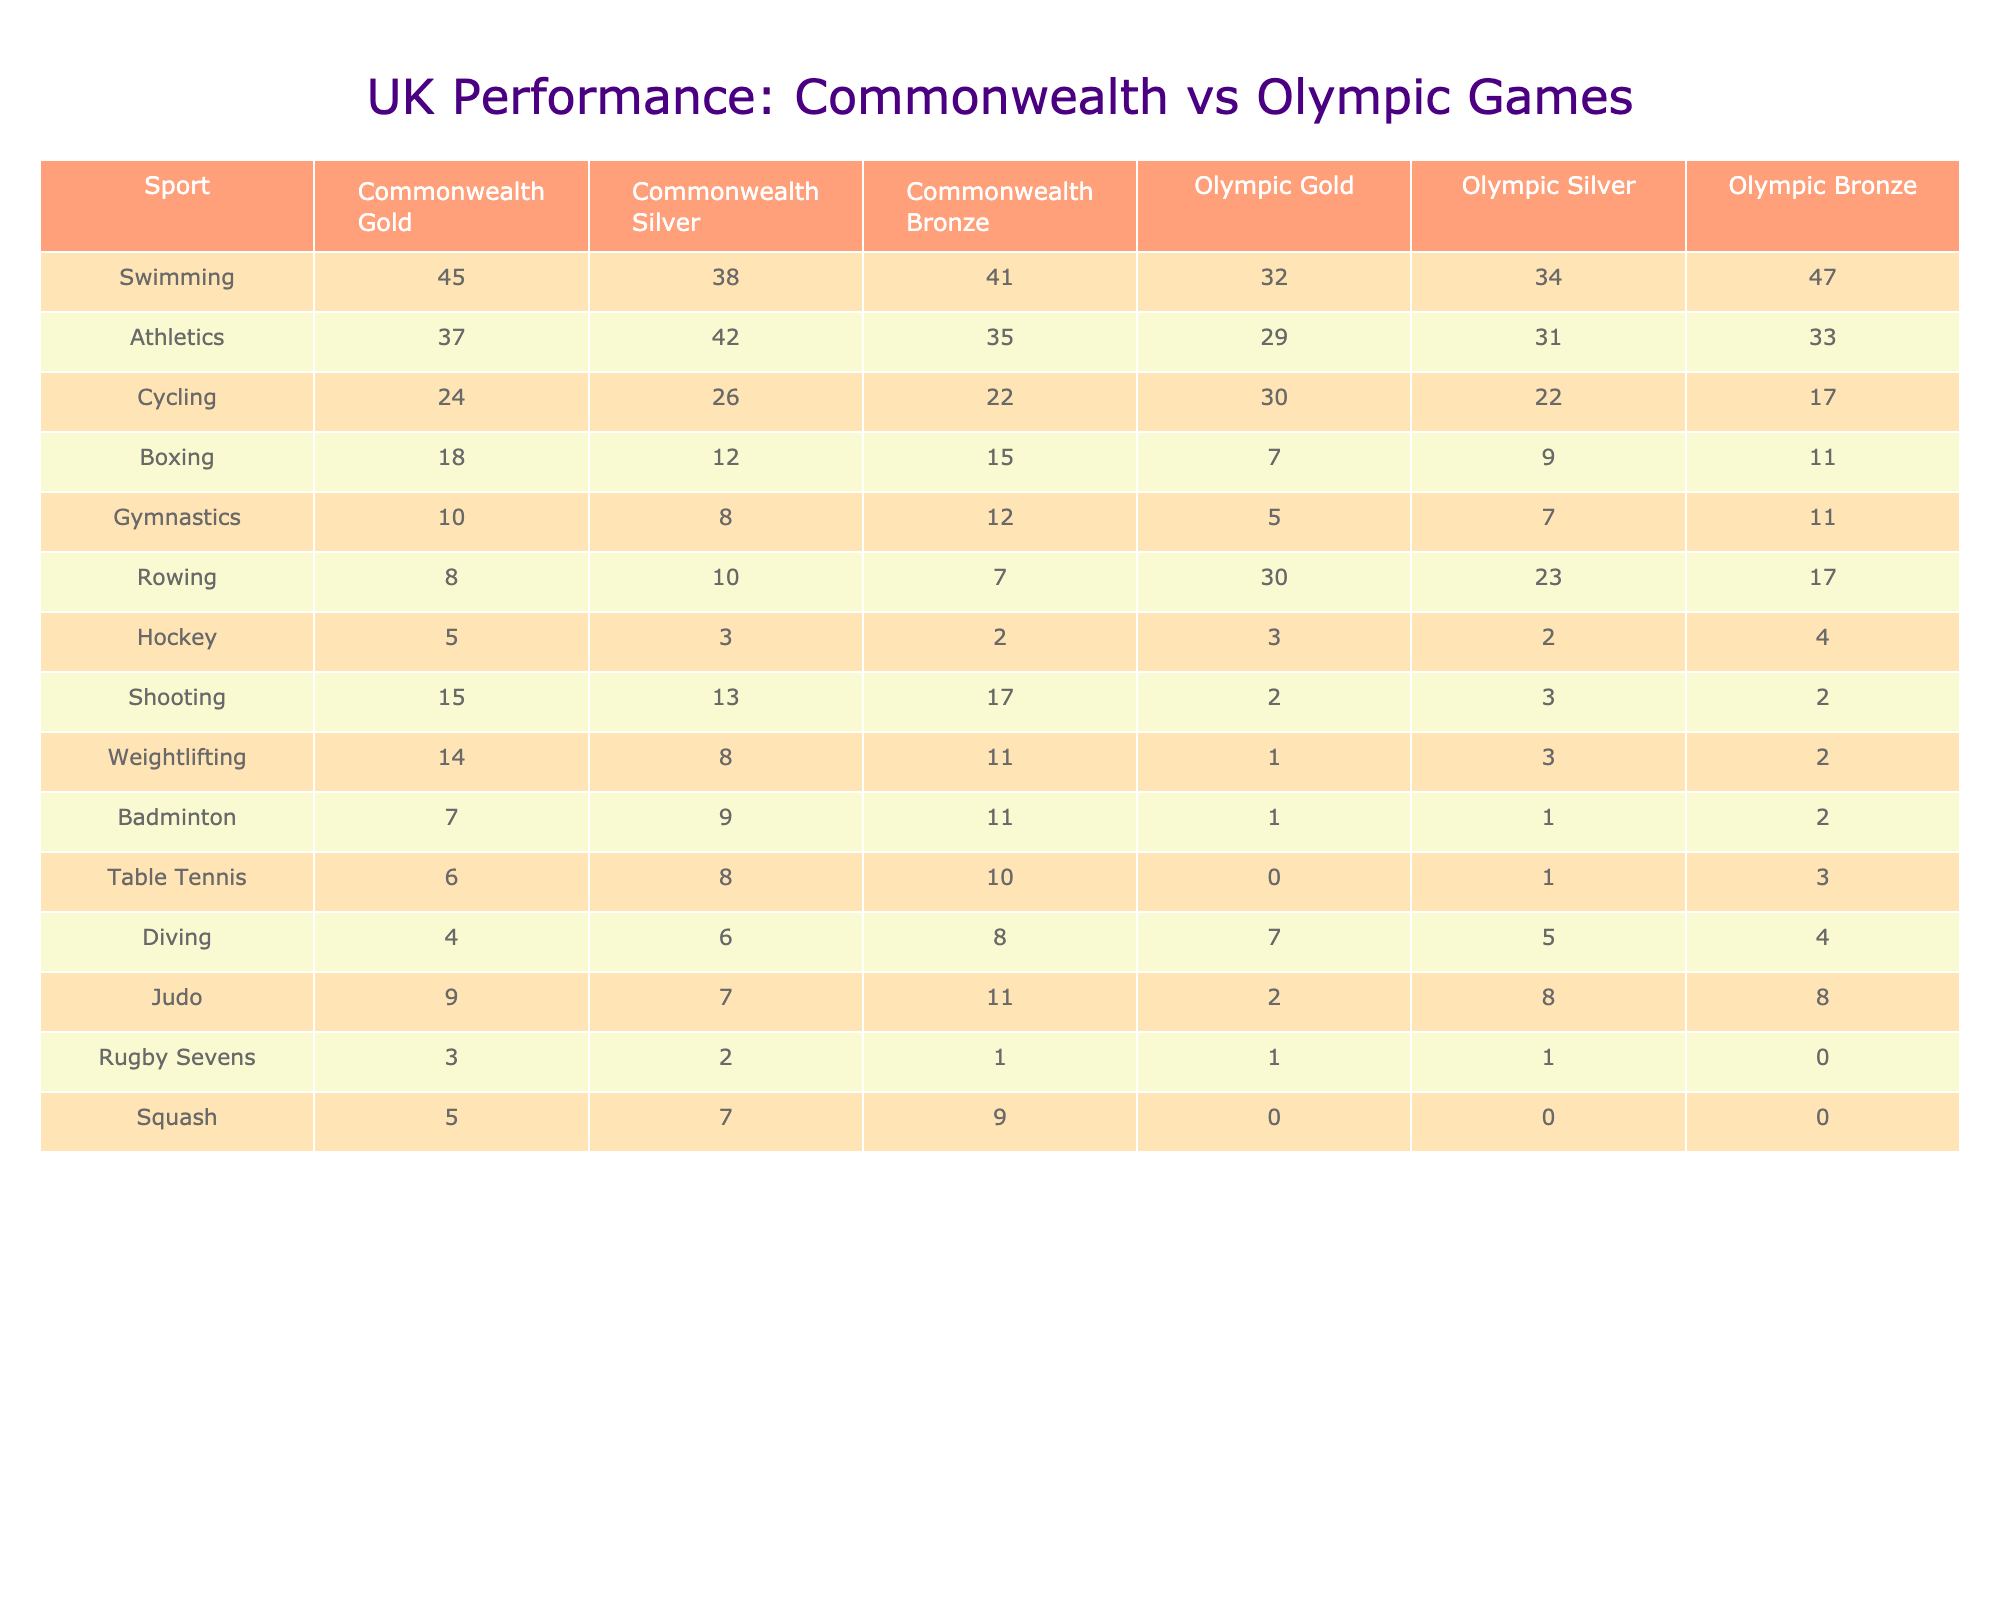What sport earned the most Commonwealth Gold medals for the UK? By looking at the table, Swimming has the highest number of Commonwealth Gold medals with a total of 45.
Answer: Swimming How many Olympic Silver medals did the UK win in Athletics? The table shows that the UK won 31 Olympic Silver medals in Athletics.
Answer: 31 What is the total number of Gold medals won by the UK in all sports across both Commonwealth and Olympic Games? To find the total Gold medals, we sum the Gold medals from both games: (45 + 37 + 24 + 18 + 10 + 8 + 5 + 15 + 14 + 7 + 6 + 4 + 9 + 3 + 5) =  4 + 5 + 6 + 7 + 8 + 15 + 18 + 24 + 37 + 45 =  5 + 8 + 9 + 15 + 24 + 2 + 31 = 223
Answer: 223 In which sport does the UK have a higher number of Commonwealth Bronze medals compared to Olympic Bronze medals? By comparing the two columns, the sport of Hockey has 2 Commonwealth Bronze medals, while it has 4 Olympic Bronze medals. The only exception with more Bronze medals in Commonwealth is Hockey, where UK has 2 compared to 4.
Answer: Hockey Which sport has the largest difference between Commonwealth Gold and Olympic Gold medals for the UK? To find the largest difference, subtract the Olympic Gold from the Commonwealth Gold for each sport: Swimming (45 - 32 = 13), Athletics (37 - 29 = 8), Cycling (24 - 30 = -6), Boxing (18 - 7 = 11), ... The largest difference is in Swimming with a difference of 13.
Answer: Swimming Did the UK win more total medals in the Commonwealth Games or in the Olympic Games? First, we calculate the total medals for both Games. Commonwealth Games: 45 + 38 + 41 + 18 + 10 + 8 + 5 + 15 + 14 + 7 + 6 + 4 + 9 + 3 + 5 = 0 = 213. Olympic Games: 32 + 34 + 47 + 7 + 5 + 11 + 3 + 2 + 3 + 1 + 0 + 5 + 2 + 1 + 0 = 339. Thus, the UK won more medals at the Olympic Games.
Answer: Olympic Games Which sport had the highest total count of medals in both Commonwealth Games and Olympic Games combined? By looking at the combined totals for all sports, we add Commonwealth and Olympic totals. Swimming has the highest total with 45 Gold, 38 Silver, and 41 Bronze in Commonwealth, and 32 Gold, 34 Silver, and 47 Bronze in Olympics, resulting in: 45 + 38 + 41 + 32 + 34 + 47 = 237, leading to Swimming being the sport with the most medals
Answer: Swimming What percentage of the total Olympic medals in Hockey were Silver? To find this percentage, first calculate the total Olympic medals: (3 + 2 + 4 = 9). The number of Silver medals is 2. Thus, the percentage is (2/9)*100 = 22.22%.
Answer: 22.22% 